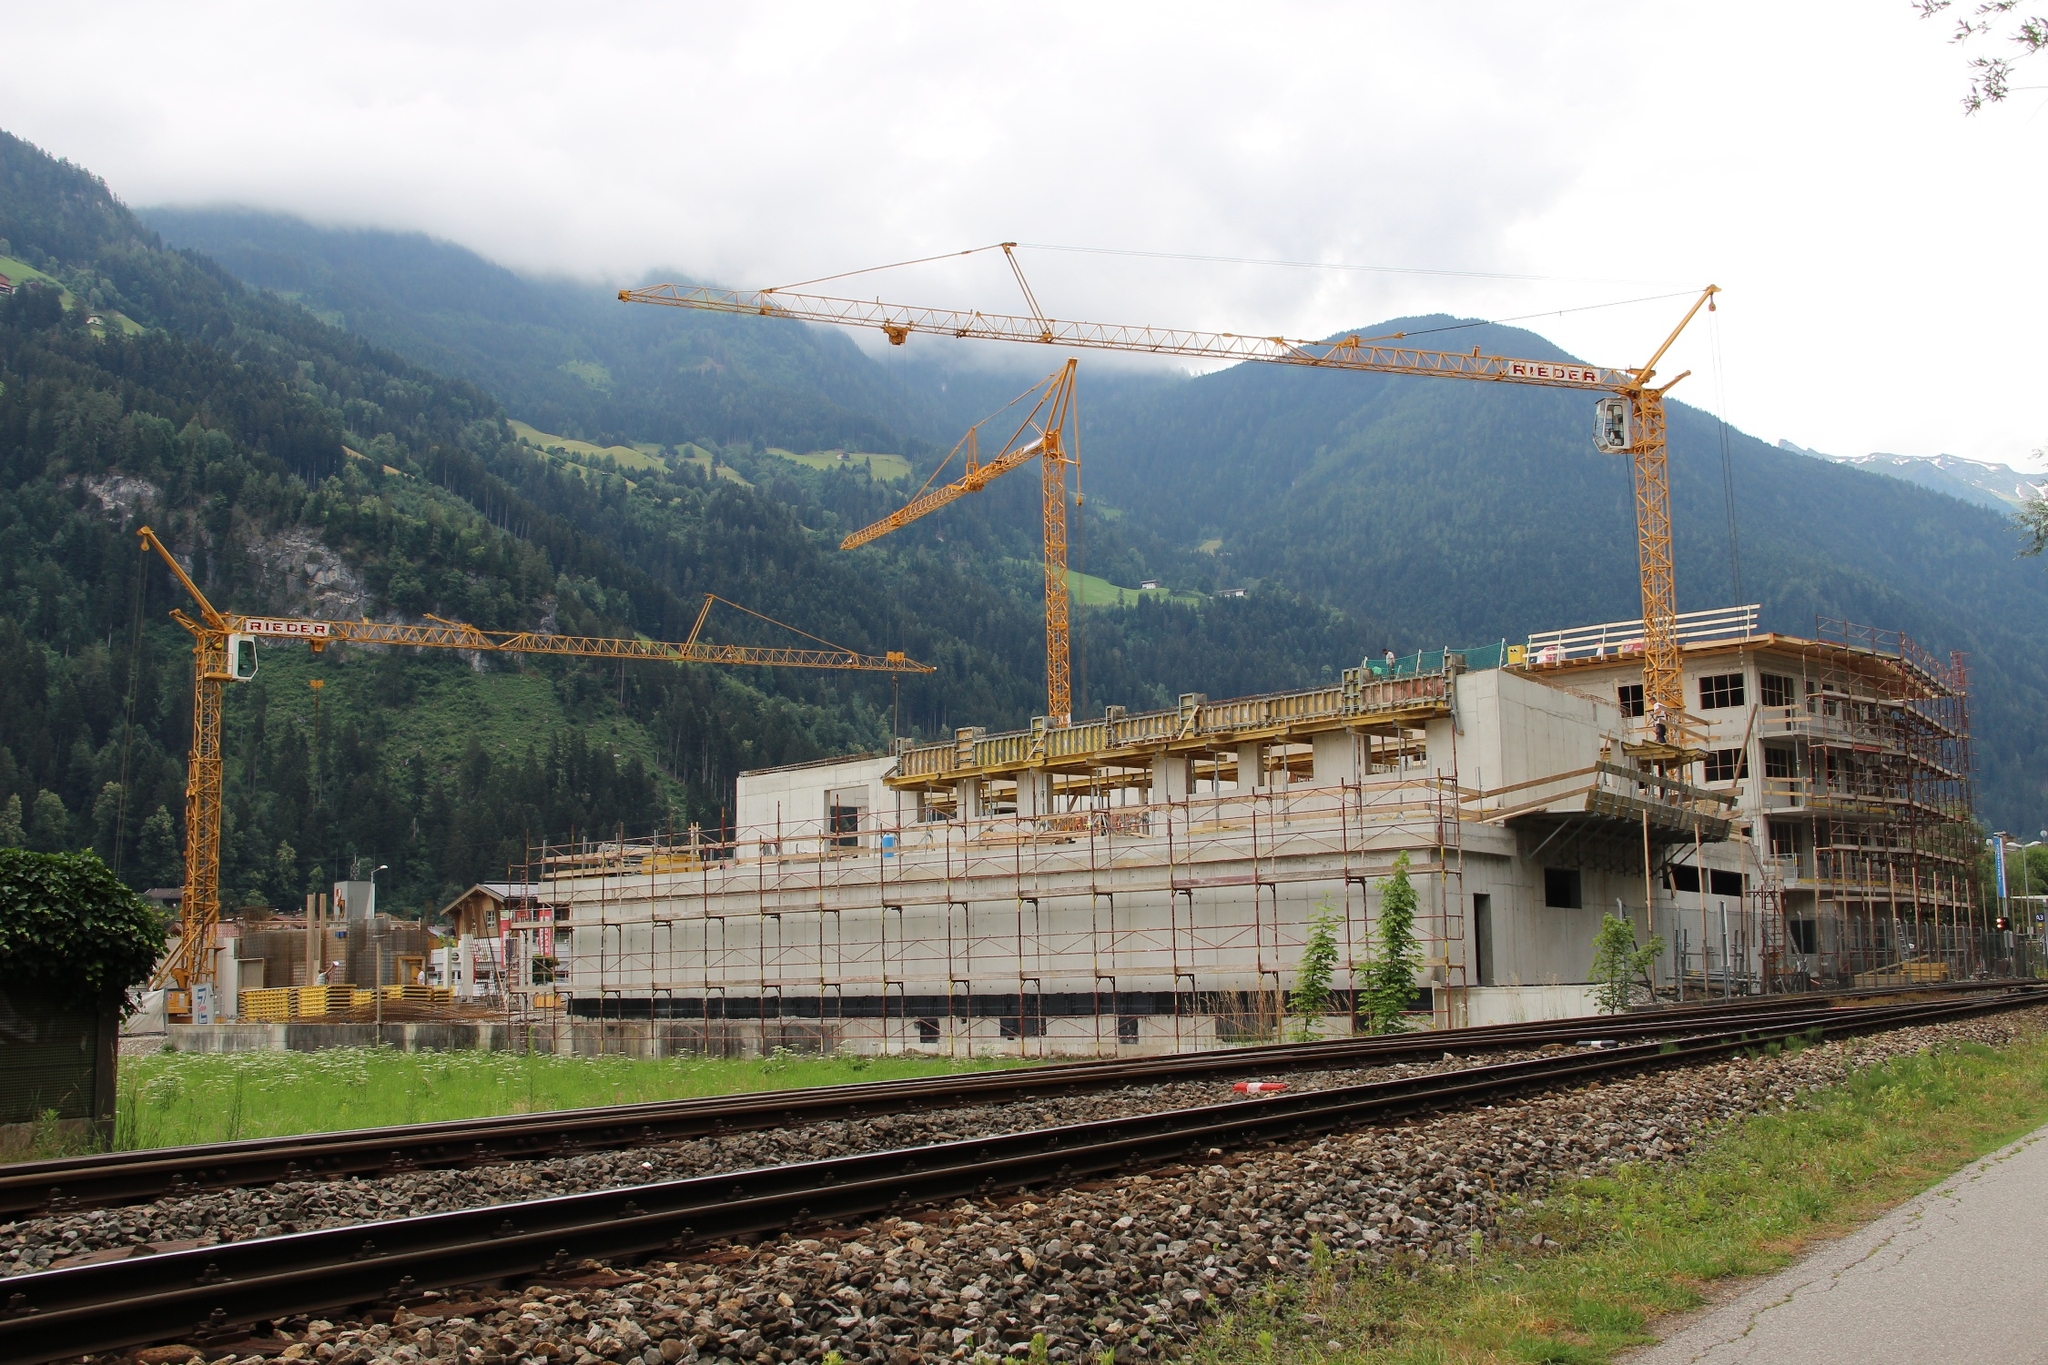Summarize the scene realistically, focusing on a practical aspect. The image shows an ongoing construction project within a mountainous region. The site is active, with several cranes facilitating the building process. Scaffolding envelops the developing structure, hinting at the construction phase. A train track runs in the foreground, which suggests ease of transportation for materials and personnel to the site. The surrounding natural environment emphasizes the project’s need to balance industrial progress with environmental considerations. 